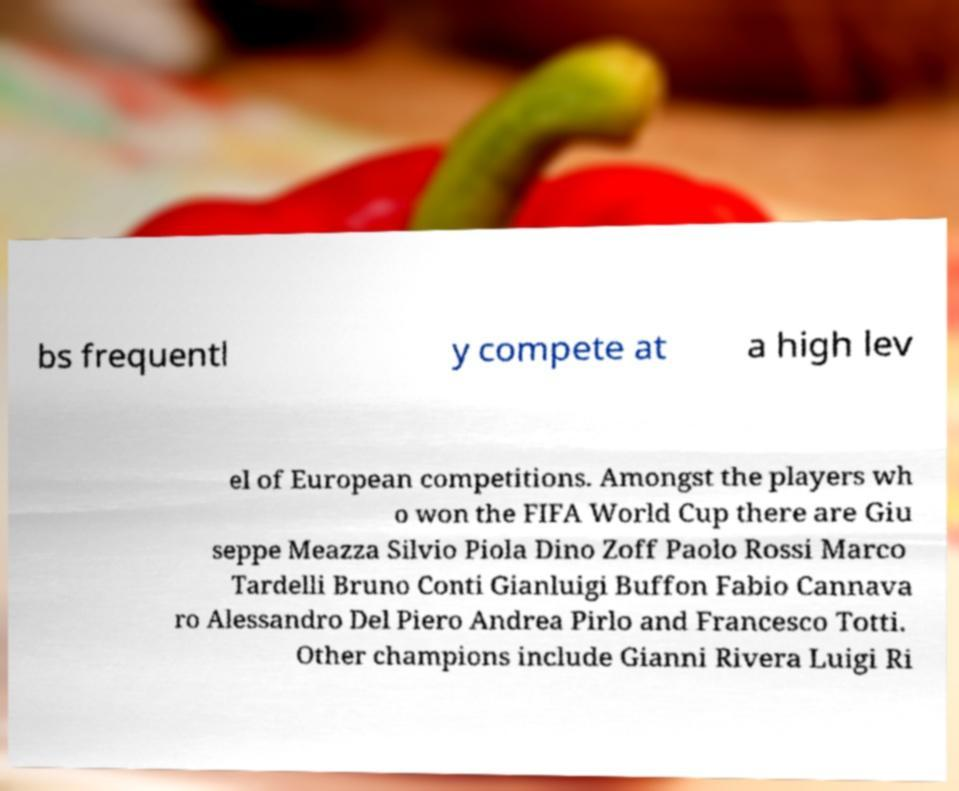Can you read and provide the text displayed in the image?This photo seems to have some interesting text. Can you extract and type it out for me? bs frequentl y compete at a high lev el of European competitions. Amongst the players wh o won the FIFA World Cup there are Giu seppe Meazza Silvio Piola Dino Zoff Paolo Rossi Marco Tardelli Bruno Conti Gianluigi Buffon Fabio Cannava ro Alessandro Del Piero Andrea Pirlo and Francesco Totti. Other champions include Gianni Rivera Luigi Ri 